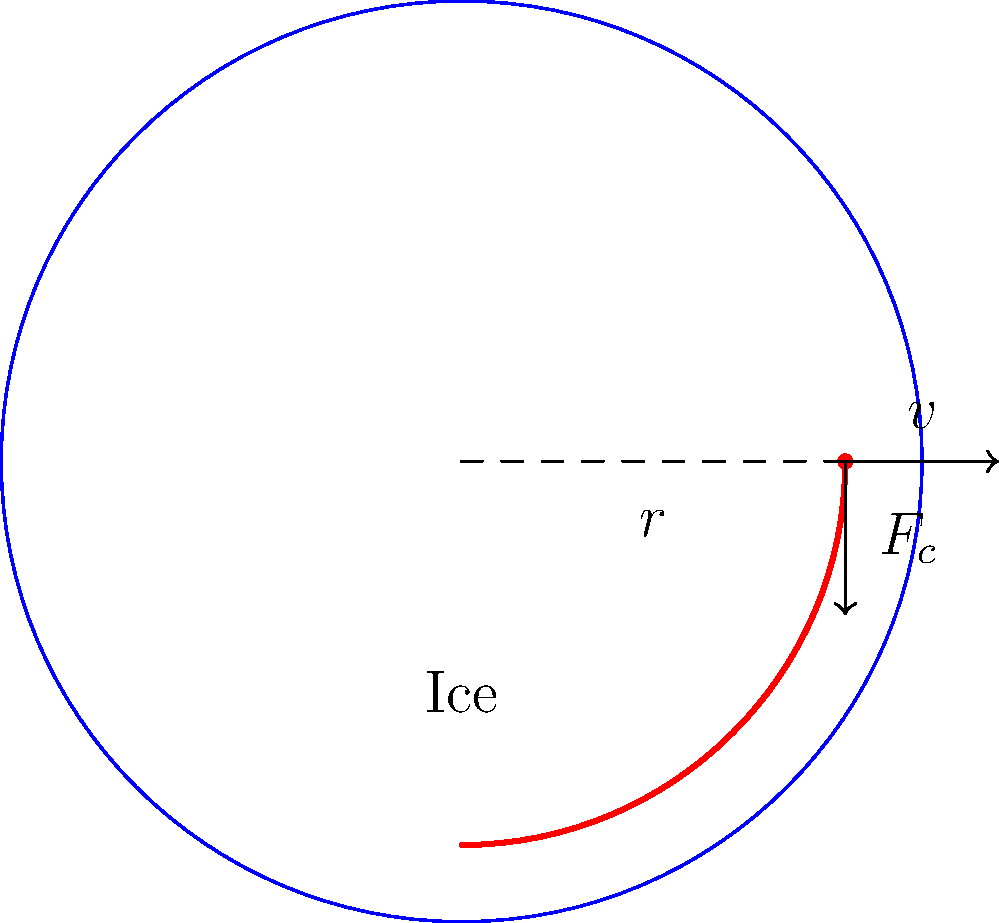During a crucial match at the Isomäki Areena, an Ässät player makes a sharp turn on the ice. If the player's mass is 90 kg, the radius of the turn is 5 m, and the player's speed is 8 m/s, what is the centripetal force experienced by the player? To solve this problem, we'll use the formula for centripetal force:

$$ F_c = \frac{mv^2}{r} $$

Where:
$F_c$ = centripetal force
$m$ = mass of the player
$v$ = velocity of the player
$r$ = radius of the turn

Step 1: Identify the given values
- Mass (m) = 90 kg
- Radius (r) = 5 m
- Velocity (v) = 8 m/s

Step 2: Substitute the values into the formula
$$ F_c = \frac{90 \text{ kg} \times (8 \text{ m/s})^2}{5 \text{ m}} $$

Step 3: Calculate the squared velocity
$$ F_c = \frac{90 \text{ kg} \times 64 \text{ m}^2/\text{s}^2}{5 \text{ m}} $$

Step 4: Multiply the numerator
$$ F_c = \frac{5760 \text{ kg}\cdot\text{m}/\text{s}^2}{5 \text{ m}} $$

Step 5: Divide to get the final answer
$$ F_c = 1152 \text{ N} $$

The centripetal force experienced by the Ässät player during the turn is 1152 N.
Answer: 1152 N 